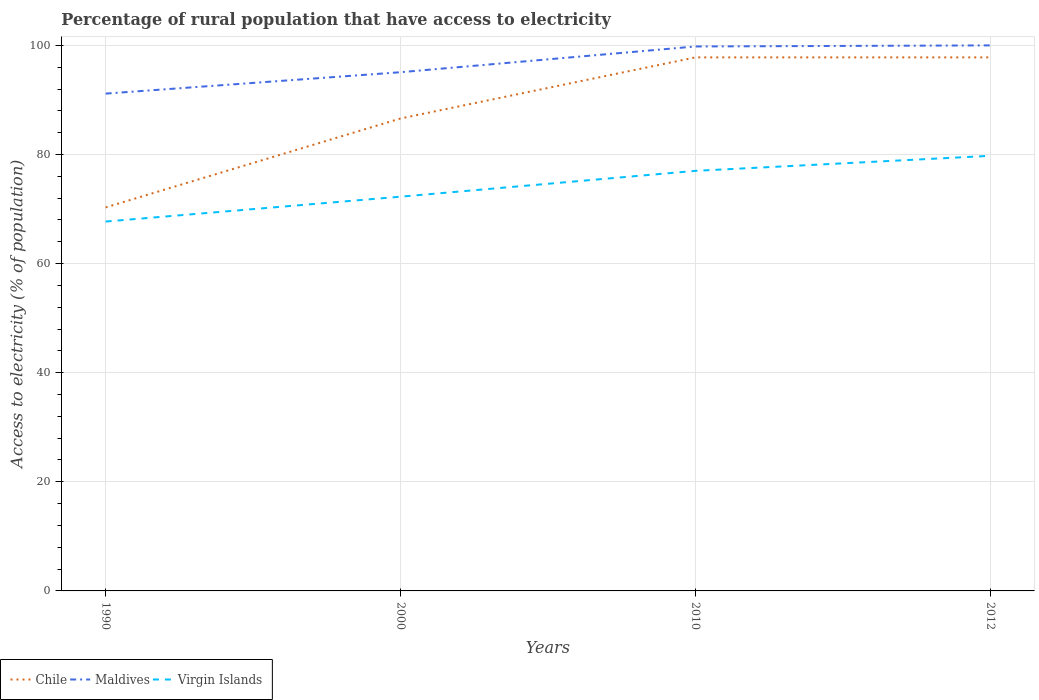How many different coloured lines are there?
Make the answer very short. 3. Is the number of lines equal to the number of legend labels?
Offer a terse response. Yes. Across all years, what is the maximum percentage of rural population that have access to electricity in Virgin Islands?
Make the answer very short. 67.71. What is the total percentage of rural population that have access to electricity in Maldives in the graph?
Offer a very short reply. -8.84. What is the difference between the highest and the second highest percentage of rural population that have access to electricity in Maldives?
Provide a succinct answer. 8.84. What is the difference between the highest and the lowest percentage of rural population that have access to electricity in Chile?
Offer a terse response. 2. Is the percentage of rural population that have access to electricity in Virgin Islands strictly greater than the percentage of rural population that have access to electricity in Maldives over the years?
Make the answer very short. Yes. How many years are there in the graph?
Keep it short and to the point. 4. What is the difference between two consecutive major ticks on the Y-axis?
Keep it short and to the point. 20. Does the graph contain grids?
Offer a terse response. Yes. Where does the legend appear in the graph?
Your answer should be compact. Bottom left. How are the legend labels stacked?
Your answer should be compact. Horizontal. What is the title of the graph?
Provide a short and direct response. Percentage of rural population that have access to electricity. What is the label or title of the X-axis?
Give a very brief answer. Years. What is the label or title of the Y-axis?
Make the answer very short. Access to electricity (% of population). What is the Access to electricity (% of population) of Chile in 1990?
Give a very brief answer. 70.3. What is the Access to electricity (% of population) of Maldives in 1990?
Provide a succinct answer. 91.16. What is the Access to electricity (% of population) of Virgin Islands in 1990?
Make the answer very short. 67.71. What is the Access to electricity (% of population) of Chile in 2000?
Your response must be concise. 86.6. What is the Access to electricity (% of population) in Maldives in 2000?
Provide a short and direct response. 95.08. What is the Access to electricity (% of population) of Virgin Islands in 2000?
Offer a very short reply. 72.27. What is the Access to electricity (% of population) in Chile in 2010?
Offer a terse response. 97.8. What is the Access to electricity (% of population) in Maldives in 2010?
Your answer should be compact. 99.8. What is the Access to electricity (% of population) of Chile in 2012?
Provide a short and direct response. 97.8. What is the Access to electricity (% of population) of Virgin Islands in 2012?
Keep it short and to the point. 79.75. Across all years, what is the maximum Access to electricity (% of population) in Chile?
Your answer should be compact. 97.8. Across all years, what is the maximum Access to electricity (% of population) in Virgin Islands?
Provide a succinct answer. 79.75. Across all years, what is the minimum Access to electricity (% of population) in Chile?
Your answer should be compact. 70.3. Across all years, what is the minimum Access to electricity (% of population) of Maldives?
Give a very brief answer. 91.16. Across all years, what is the minimum Access to electricity (% of population) in Virgin Islands?
Offer a very short reply. 67.71. What is the total Access to electricity (% of population) in Chile in the graph?
Your response must be concise. 352.5. What is the total Access to electricity (% of population) in Maldives in the graph?
Your response must be concise. 386.04. What is the total Access to electricity (% of population) in Virgin Islands in the graph?
Provide a succinct answer. 296.73. What is the difference between the Access to electricity (% of population) in Chile in 1990 and that in 2000?
Make the answer very short. -16.3. What is the difference between the Access to electricity (% of population) in Maldives in 1990 and that in 2000?
Keep it short and to the point. -3.92. What is the difference between the Access to electricity (% of population) of Virgin Islands in 1990 and that in 2000?
Offer a terse response. -4.55. What is the difference between the Access to electricity (% of population) in Chile in 1990 and that in 2010?
Provide a short and direct response. -27.5. What is the difference between the Access to electricity (% of population) in Maldives in 1990 and that in 2010?
Offer a very short reply. -8.64. What is the difference between the Access to electricity (% of population) in Virgin Islands in 1990 and that in 2010?
Give a very brief answer. -9.29. What is the difference between the Access to electricity (% of population) in Chile in 1990 and that in 2012?
Give a very brief answer. -27.5. What is the difference between the Access to electricity (% of population) of Maldives in 1990 and that in 2012?
Your answer should be compact. -8.84. What is the difference between the Access to electricity (% of population) of Virgin Islands in 1990 and that in 2012?
Offer a terse response. -12.04. What is the difference between the Access to electricity (% of population) in Maldives in 2000 and that in 2010?
Your answer should be very brief. -4.72. What is the difference between the Access to electricity (% of population) in Virgin Islands in 2000 and that in 2010?
Your answer should be very brief. -4.74. What is the difference between the Access to electricity (% of population) in Chile in 2000 and that in 2012?
Your answer should be very brief. -11.2. What is the difference between the Access to electricity (% of population) in Maldives in 2000 and that in 2012?
Your response must be concise. -4.92. What is the difference between the Access to electricity (% of population) of Virgin Islands in 2000 and that in 2012?
Give a very brief answer. -7.49. What is the difference between the Access to electricity (% of population) in Virgin Islands in 2010 and that in 2012?
Offer a terse response. -2.75. What is the difference between the Access to electricity (% of population) of Chile in 1990 and the Access to electricity (% of population) of Maldives in 2000?
Give a very brief answer. -24.78. What is the difference between the Access to electricity (% of population) of Chile in 1990 and the Access to electricity (% of population) of Virgin Islands in 2000?
Ensure brevity in your answer.  -1.97. What is the difference between the Access to electricity (% of population) in Maldives in 1990 and the Access to electricity (% of population) in Virgin Islands in 2000?
Your answer should be compact. 18.9. What is the difference between the Access to electricity (% of population) of Chile in 1990 and the Access to electricity (% of population) of Maldives in 2010?
Ensure brevity in your answer.  -29.5. What is the difference between the Access to electricity (% of population) in Chile in 1990 and the Access to electricity (% of population) in Virgin Islands in 2010?
Ensure brevity in your answer.  -6.7. What is the difference between the Access to electricity (% of population) of Maldives in 1990 and the Access to electricity (% of population) of Virgin Islands in 2010?
Keep it short and to the point. 14.16. What is the difference between the Access to electricity (% of population) of Chile in 1990 and the Access to electricity (% of population) of Maldives in 2012?
Keep it short and to the point. -29.7. What is the difference between the Access to electricity (% of population) of Chile in 1990 and the Access to electricity (% of population) of Virgin Islands in 2012?
Make the answer very short. -9.45. What is the difference between the Access to electricity (% of population) in Maldives in 1990 and the Access to electricity (% of population) in Virgin Islands in 2012?
Offer a very short reply. 11.41. What is the difference between the Access to electricity (% of population) in Chile in 2000 and the Access to electricity (% of population) in Virgin Islands in 2010?
Provide a succinct answer. 9.6. What is the difference between the Access to electricity (% of population) in Maldives in 2000 and the Access to electricity (% of population) in Virgin Islands in 2010?
Your response must be concise. 18.08. What is the difference between the Access to electricity (% of population) of Chile in 2000 and the Access to electricity (% of population) of Maldives in 2012?
Give a very brief answer. -13.4. What is the difference between the Access to electricity (% of population) of Chile in 2000 and the Access to electricity (% of population) of Virgin Islands in 2012?
Give a very brief answer. 6.85. What is the difference between the Access to electricity (% of population) in Maldives in 2000 and the Access to electricity (% of population) in Virgin Islands in 2012?
Ensure brevity in your answer.  15.33. What is the difference between the Access to electricity (% of population) of Chile in 2010 and the Access to electricity (% of population) of Maldives in 2012?
Give a very brief answer. -2.2. What is the difference between the Access to electricity (% of population) in Chile in 2010 and the Access to electricity (% of population) in Virgin Islands in 2012?
Ensure brevity in your answer.  18.05. What is the difference between the Access to electricity (% of population) in Maldives in 2010 and the Access to electricity (% of population) in Virgin Islands in 2012?
Your answer should be very brief. 20.05. What is the average Access to electricity (% of population) in Chile per year?
Make the answer very short. 88.12. What is the average Access to electricity (% of population) in Maldives per year?
Your answer should be very brief. 96.51. What is the average Access to electricity (% of population) of Virgin Islands per year?
Give a very brief answer. 74.18. In the year 1990, what is the difference between the Access to electricity (% of population) of Chile and Access to electricity (% of population) of Maldives?
Give a very brief answer. -20.86. In the year 1990, what is the difference between the Access to electricity (% of population) of Chile and Access to electricity (% of population) of Virgin Islands?
Make the answer very short. 2.59. In the year 1990, what is the difference between the Access to electricity (% of population) in Maldives and Access to electricity (% of population) in Virgin Islands?
Your response must be concise. 23.45. In the year 2000, what is the difference between the Access to electricity (% of population) of Chile and Access to electricity (% of population) of Maldives?
Give a very brief answer. -8.48. In the year 2000, what is the difference between the Access to electricity (% of population) of Chile and Access to electricity (% of population) of Virgin Islands?
Offer a terse response. 14.34. In the year 2000, what is the difference between the Access to electricity (% of population) of Maldives and Access to electricity (% of population) of Virgin Islands?
Offer a very short reply. 22.82. In the year 2010, what is the difference between the Access to electricity (% of population) in Chile and Access to electricity (% of population) in Maldives?
Ensure brevity in your answer.  -2. In the year 2010, what is the difference between the Access to electricity (% of population) in Chile and Access to electricity (% of population) in Virgin Islands?
Keep it short and to the point. 20.8. In the year 2010, what is the difference between the Access to electricity (% of population) in Maldives and Access to electricity (% of population) in Virgin Islands?
Offer a very short reply. 22.8. In the year 2012, what is the difference between the Access to electricity (% of population) in Chile and Access to electricity (% of population) in Virgin Islands?
Your answer should be compact. 18.05. In the year 2012, what is the difference between the Access to electricity (% of population) of Maldives and Access to electricity (% of population) of Virgin Islands?
Make the answer very short. 20.25. What is the ratio of the Access to electricity (% of population) in Chile in 1990 to that in 2000?
Ensure brevity in your answer.  0.81. What is the ratio of the Access to electricity (% of population) of Maldives in 1990 to that in 2000?
Give a very brief answer. 0.96. What is the ratio of the Access to electricity (% of population) in Virgin Islands in 1990 to that in 2000?
Your answer should be very brief. 0.94. What is the ratio of the Access to electricity (% of population) in Chile in 1990 to that in 2010?
Offer a terse response. 0.72. What is the ratio of the Access to electricity (% of population) of Maldives in 1990 to that in 2010?
Provide a short and direct response. 0.91. What is the ratio of the Access to electricity (% of population) of Virgin Islands in 1990 to that in 2010?
Make the answer very short. 0.88. What is the ratio of the Access to electricity (% of population) of Chile in 1990 to that in 2012?
Ensure brevity in your answer.  0.72. What is the ratio of the Access to electricity (% of population) in Maldives in 1990 to that in 2012?
Your response must be concise. 0.91. What is the ratio of the Access to electricity (% of population) of Virgin Islands in 1990 to that in 2012?
Provide a succinct answer. 0.85. What is the ratio of the Access to electricity (% of population) in Chile in 2000 to that in 2010?
Your response must be concise. 0.89. What is the ratio of the Access to electricity (% of population) in Maldives in 2000 to that in 2010?
Your answer should be compact. 0.95. What is the ratio of the Access to electricity (% of population) in Virgin Islands in 2000 to that in 2010?
Offer a very short reply. 0.94. What is the ratio of the Access to electricity (% of population) in Chile in 2000 to that in 2012?
Your response must be concise. 0.89. What is the ratio of the Access to electricity (% of population) of Maldives in 2000 to that in 2012?
Give a very brief answer. 0.95. What is the ratio of the Access to electricity (% of population) of Virgin Islands in 2000 to that in 2012?
Ensure brevity in your answer.  0.91. What is the ratio of the Access to electricity (% of population) of Virgin Islands in 2010 to that in 2012?
Give a very brief answer. 0.97. What is the difference between the highest and the second highest Access to electricity (% of population) of Maldives?
Your answer should be compact. 0.2. What is the difference between the highest and the second highest Access to electricity (% of population) in Virgin Islands?
Provide a short and direct response. 2.75. What is the difference between the highest and the lowest Access to electricity (% of population) in Maldives?
Your answer should be compact. 8.84. What is the difference between the highest and the lowest Access to electricity (% of population) in Virgin Islands?
Offer a very short reply. 12.04. 